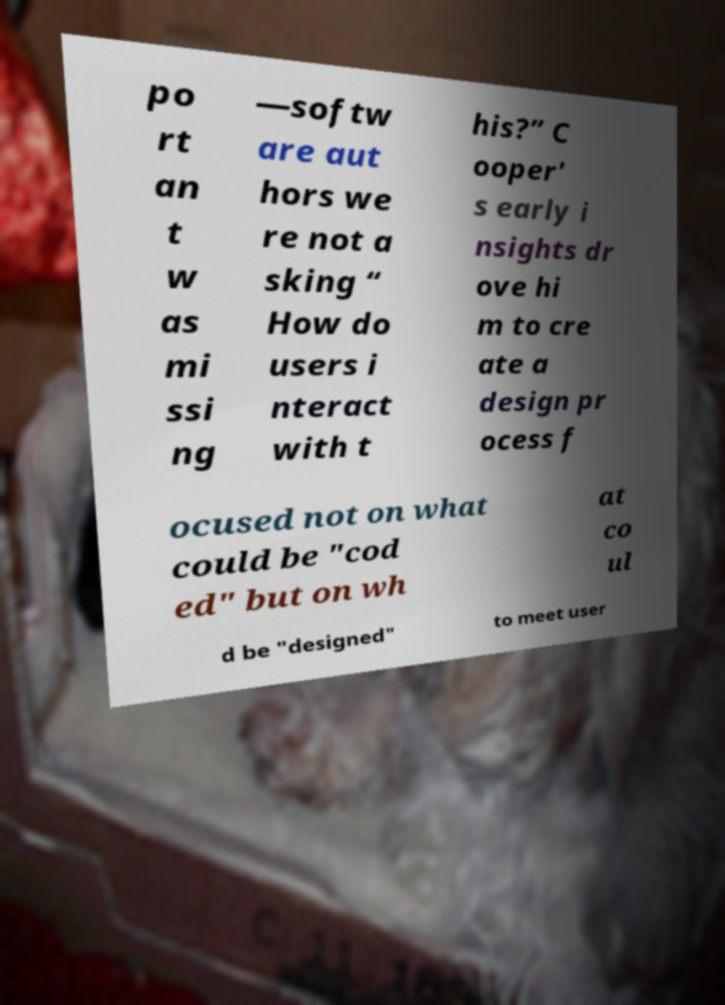Can you accurately transcribe the text from the provided image for me? po rt an t w as mi ssi ng —softw are aut hors we re not a sking “ How do users i nteract with t his?” C ooper' s early i nsights dr ove hi m to cre ate a design pr ocess f ocused not on what could be "cod ed" but on wh at co ul d be "designed" to meet user 